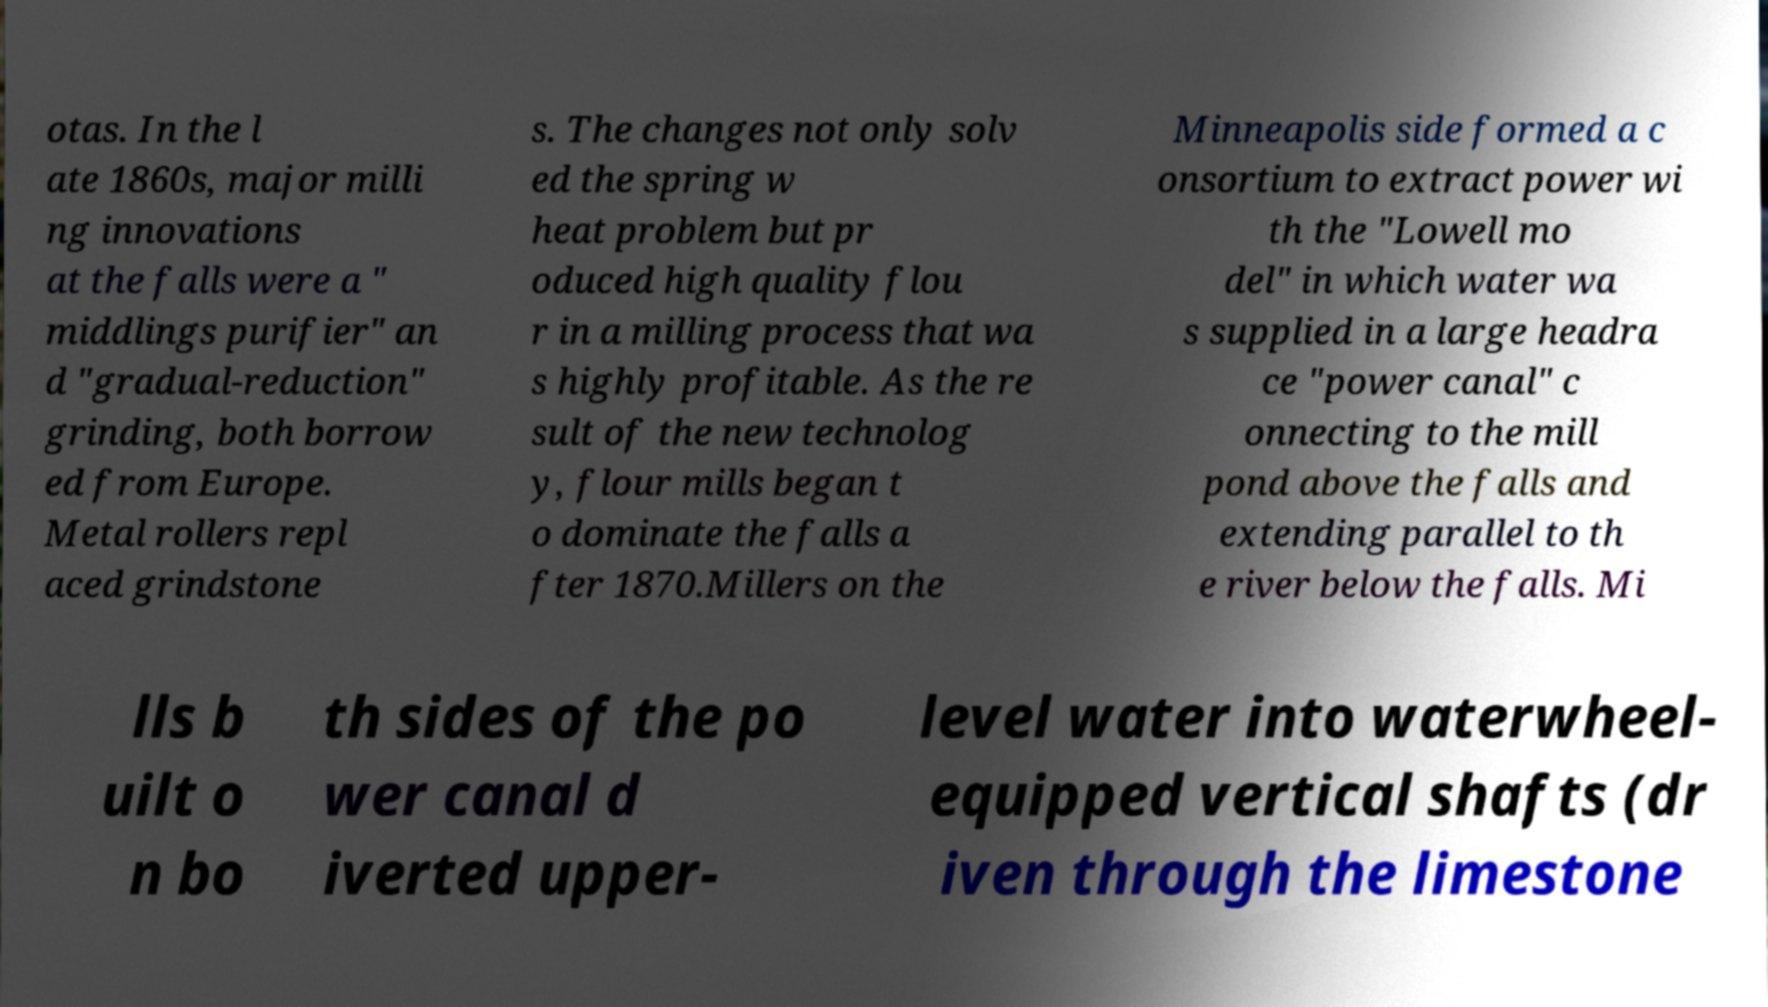Please read and relay the text visible in this image. What does it say? otas. In the l ate 1860s, major milli ng innovations at the falls were a " middlings purifier" an d "gradual-reduction" grinding, both borrow ed from Europe. Metal rollers repl aced grindstone s. The changes not only solv ed the spring w heat problem but pr oduced high quality flou r in a milling process that wa s highly profitable. As the re sult of the new technolog y, flour mills began t o dominate the falls a fter 1870.Millers on the Minneapolis side formed a c onsortium to extract power wi th the "Lowell mo del" in which water wa s supplied in a large headra ce "power canal" c onnecting to the mill pond above the falls and extending parallel to th e river below the falls. Mi lls b uilt o n bo th sides of the po wer canal d iverted upper- level water into waterwheel- equipped vertical shafts (dr iven through the limestone 